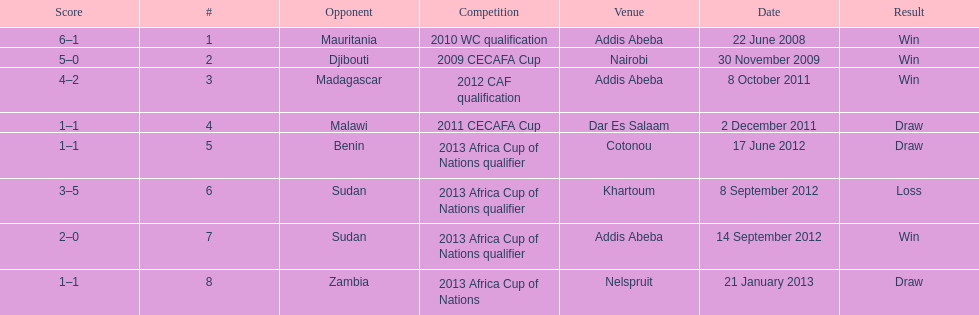How long in years down this table cover? 5. 